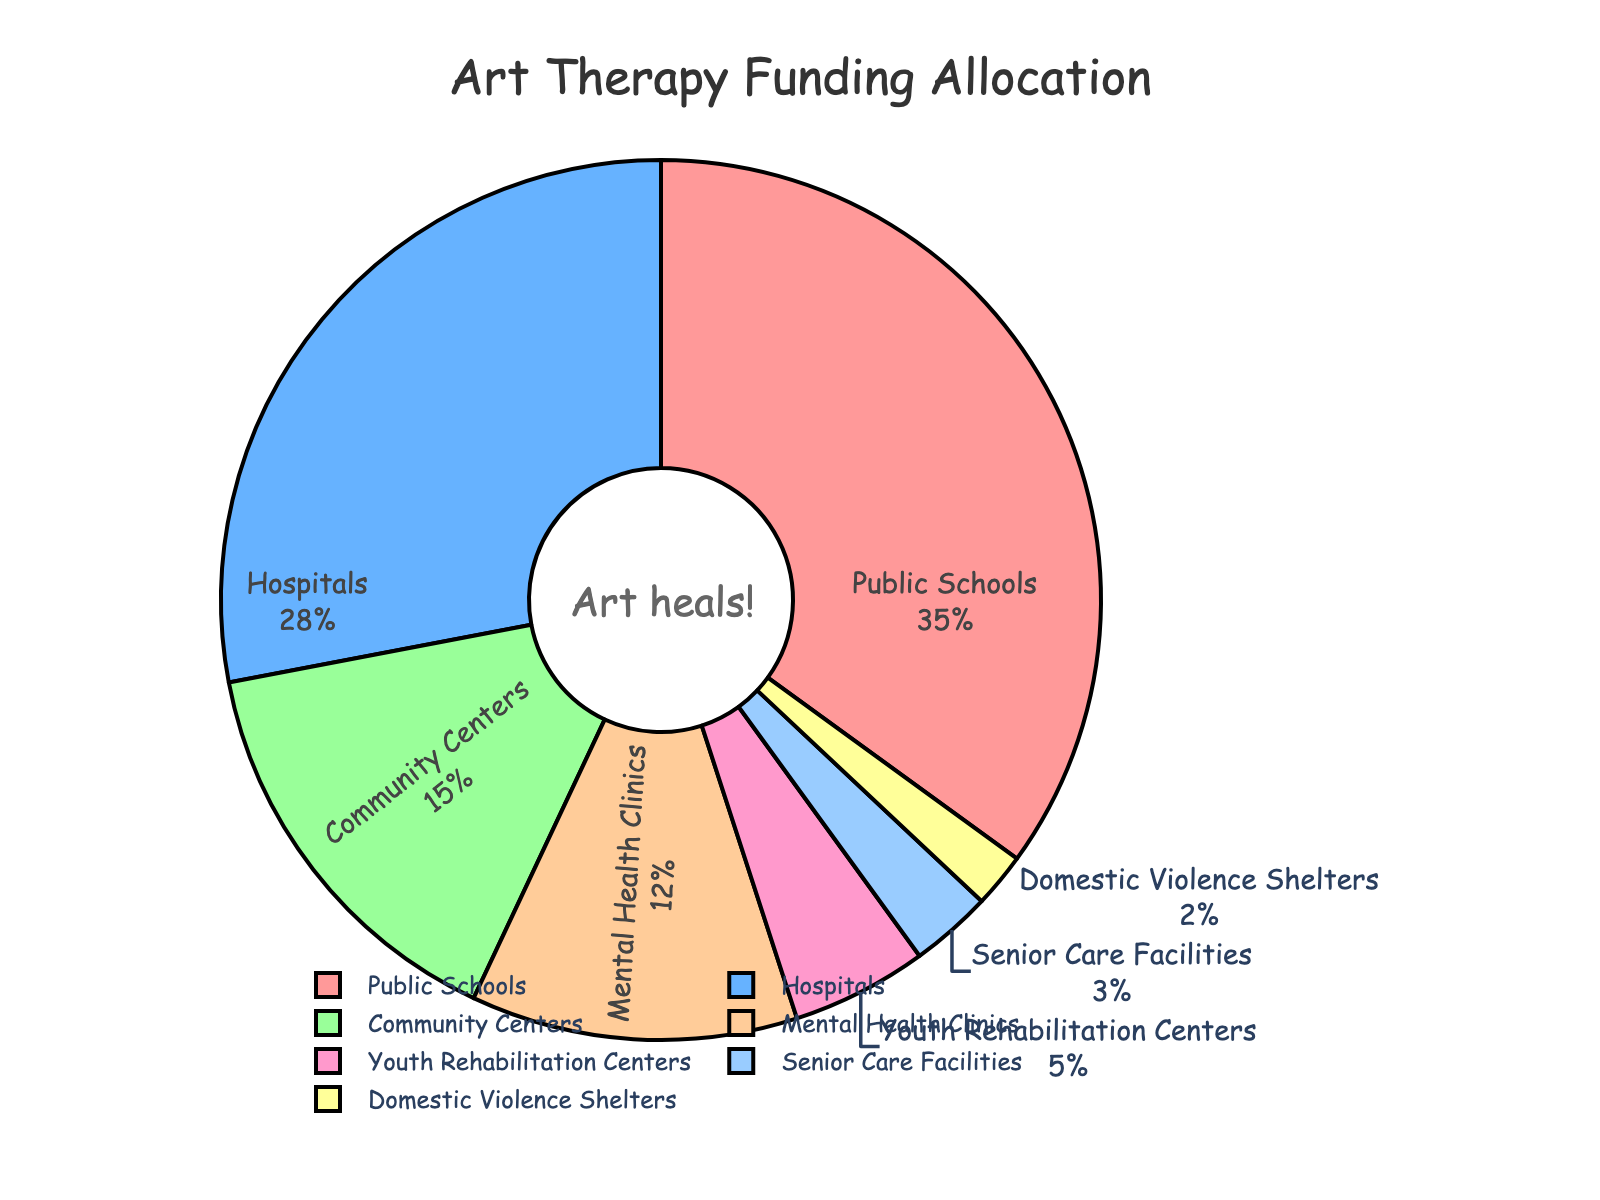What's the largest allocation of funding by setting? The largest slice of the pie corresponds to Public Schools, which shows a 35% allocation. The percentage value is part of the visual information in the figure.
Answer: Public Schools What's the total percentage allocation for Hospitals and Community Centers combined? Add the percentage for Hospitals (28%) and Community Centers (15%). 28% + 15% = 43%.
Answer: 43% Which setting receives less funding: Youth Rehabilitation Centers or Senior Care Facilities? Youth Rehabilitation Centers have a 5% allocation, and Senior Care Facilities have a 3% allocation. Thus, Senior Care Facilities receive less funding.
Answer: Senior Care Facilities What is the difference in funding allocation between Public Schools and Hospitals? Public Schools have a 35% allocation, and Hospitals have a 28% allocation. Subtracting 28% from 35% gives 7%.
Answer: 7% What's the average percentage allocation for all settings? Sum all percentage values: 35% + 28% + 15% + 12% + 5% + 3% + 2% = 100%. Since there are 7 settings, divide 100% by 7.
Answer: 14.3% How many settings have received 5% or less in funding? Identify the settings with 5% or less: Youth Rehabilitation Centers (5%), Senior Care Facilities (3%), and Domestic Violence Shelters (2%). Count these settings: 3.
Answer: 3 Which slice of the pie chart is green and what is its percentage allocation? The green slice of the pie represents Mental Health Clinics with a 12% allocation. This can be identified by matching the colors used in the chart with the labels.
Answer: Mental Health Clinics with 12% 